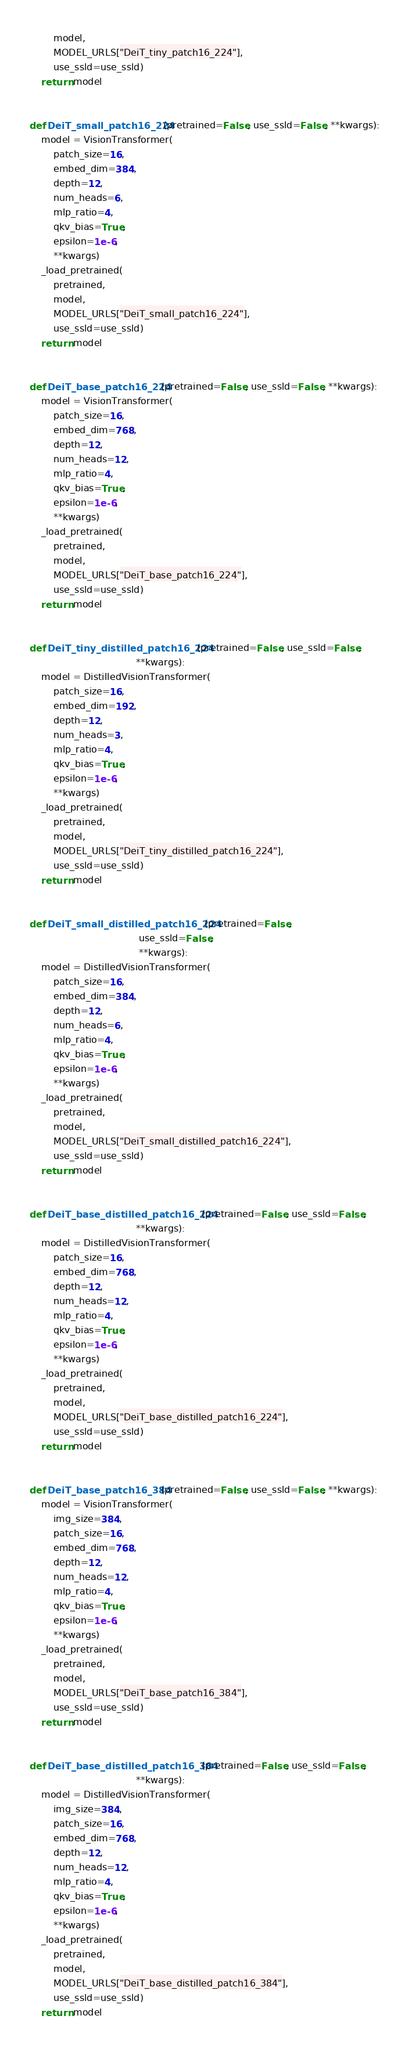<code> <loc_0><loc_0><loc_500><loc_500><_Python_>        model,
        MODEL_URLS["DeiT_tiny_patch16_224"],
        use_ssld=use_ssld)
    return model


def DeiT_small_patch16_224(pretrained=False, use_ssld=False, **kwargs):
    model = VisionTransformer(
        patch_size=16,
        embed_dim=384,
        depth=12,
        num_heads=6,
        mlp_ratio=4,
        qkv_bias=True,
        epsilon=1e-6,
        **kwargs)
    _load_pretrained(
        pretrained,
        model,
        MODEL_URLS["DeiT_small_patch16_224"],
        use_ssld=use_ssld)
    return model


def DeiT_base_patch16_224(pretrained=False, use_ssld=False, **kwargs):
    model = VisionTransformer(
        patch_size=16,
        embed_dim=768,
        depth=12,
        num_heads=12,
        mlp_ratio=4,
        qkv_bias=True,
        epsilon=1e-6,
        **kwargs)
    _load_pretrained(
        pretrained,
        model,
        MODEL_URLS["DeiT_base_patch16_224"],
        use_ssld=use_ssld)
    return model


def DeiT_tiny_distilled_patch16_224(pretrained=False, use_ssld=False,
                                    **kwargs):
    model = DistilledVisionTransformer(
        patch_size=16,
        embed_dim=192,
        depth=12,
        num_heads=3,
        mlp_ratio=4,
        qkv_bias=True,
        epsilon=1e-6,
        **kwargs)
    _load_pretrained(
        pretrained,
        model,
        MODEL_URLS["DeiT_tiny_distilled_patch16_224"],
        use_ssld=use_ssld)
    return model


def DeiT_small_distilled_patch16_224(pretrained=False,
                                     use_ssld=False,
                                     **kwargs):
    model = DistilledVisionTransformer(
        patch_size=16,
        embed_dim=384,
        depth=12,
        num_heads=6,
        mlp_ratio=4,
        qkv_bias=True,
        epsilon=1e-6,
        **kwargs)
    _load_pretrained(
        pretrained,
        model,
        MODEL_URLS["DeiT_small_distilled_patch16_224"],
        use_ssld=use_ssld)
    return model


def DeiT_base_distilled_patch16_224(pretrained=False, use_ssld=False,
                                    **kwargs):
    model = DistilledVisionTransformer(
        patch_size=16,
        embed_dim=768,
        depth=12,
        num_heads=12,
        mlp_ratio=4,
        qkv_bias=True,
        epsilon=1e-6,
        **kwargs)
    _load_pretrained(
        pretrained,
        model,
        MODEL_URLS["DeiT_base_distilled_patch16_224"],
        use_ssld=use_ssld)
    return model


def DeiT_base_patch16_384(pretrained=False, use_ssld=False, **kwargs):
    model = VisionTransformer(
        img_size=384,
        patch_size=16,
        embed_dim=768,
        depth=12,
        num_heads=12,
        mlp_ratio=4,
        qkv_bias=True,
        epsilon=1e-6,
        **kwargs)
    _load_pretrained(
        pretrained,
        model,
        MODEL_URLS["DeiT_base_patch16_384"],
        use_ssld=use_ssld)
    return model


def DeiT_base_distilled_patch16_384(pretrained=False, use_ssld=False,
                                    **kwargs):
    model = DistilledVisionTransformer(
        img_size=384,
        patch_size=16,
        embed_dim=768,
        depth=12,
        num_heads=12,
        mlp_ratio=4,
        qkv_bias=True,
        epsilon=1e-6,
        **kwargs)
    _load_pretrained(
        pretrained,
        model,
        MODEL_URLS["DeiT_base_distilled_patch16_384"],
        use_ssld=use_ssld)
    return model
</code> 